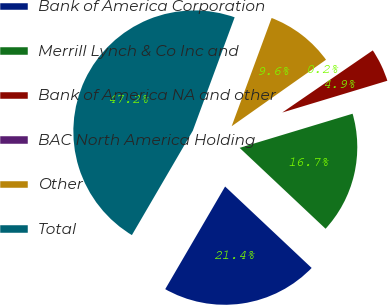Convert chart to OTSL. <chart><loc_0><loc_0><loc_500><loc_500><pie_chart><fcel>Bank of America Corporation<fcel>Merrill Lynch & Co Inc and<fcel>Bank of America NA and other<fcel>BAC North America Holding<fcel>Other<fcel>Total<nl><fcel>21.39%<fcel>16.69%<fcel>4.9%<fcel>0.2%<fcel>9.6%<fcel>47.22%<nl></chart> 